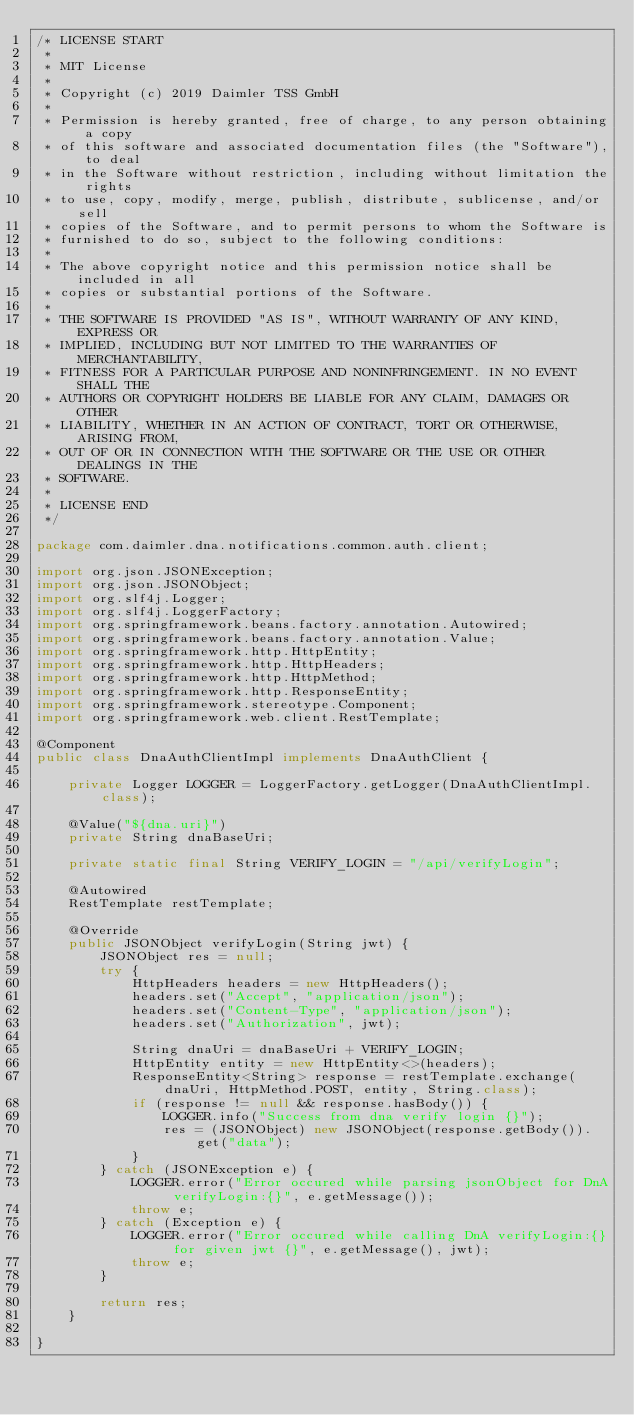Convert code to text. <code><loc_0><loc_0><loc_500><loc_500><_Java_>/* LICENSE START
 * 
 * MIT License
 * 
 * Copyright (c) 2019 Daimler TSS GmbH
 * 
 * Permission is hereby granted, free of charge, to any person obtaining a copy
 * of this software and associated documentation files (the "Software"), to deal
 * in the Software without restriction, including without limitation the rights
 * to use, copy, modify, merge, publish, distribute, sublicense, and/or sell
 * copies of the Software, and to permit persons to whom the Software is
 * furnished to do so, subject to the following conditions:
 * 
 * The above copyright notice and this permission notice shall be included in all
 * copies or substantial portions of the Software.
 * 
 * THE SOFTWARE IS PROVIDED "AS IS", WITHOUT WARRANTY OF ANY KIND, EXPRESS OR
 * IMPLIED, INCLUDING BUT NOT LIMITED TO THE WARRANTIES OF MERCHANTABILITY,
 * FITNESS FOR A PARTICULAR PURPOSE AND NONINFRINGEMENT. IN NO EVENT SHALL THE
 * AUTHORS OR COPYRIGHT HOLDERS BE LIABLE FOR ANY CLAIM, DAMAGES OR OTHER
 * LIABILITY, WHETHER IN AN ACTION OF CONTRACT, TORT OR OTHERWISE, ARISING FROM,
 * OUT OF OR IN CONNECTION WITH THE SOFTWARE OR THE USE OR OTHER DEALINGS IN THE
 * SOFTWARE.
 * 
 * LICENSE END 
 */

package com.daimler.dna.notifications.common.auth.client;

import org.json.JSONException;
import org.json.JSONObject;
import org.slf4j.Logger;
import org.slf4j.LoggerFactory;
import org.springframework.beans.factory.annotation.Autowired;
import org.springframework.beans.factory.annotation.Value;
import org.springframework.http.HttpEntity;
import org.springframework.http.HttpHeaders;
import org.springframework.http.HttpMethod;
import org.springframework.http.ResponseEntity;
import org.springframework.stereotype.Component;
import org.springframework.web.client.RestTemplate;

@Component
public class DnaAuthClientImpl implements DnaAuthClient {

	private Logger LOGGER = LoggerFactory.getLogger(DnaAuthClientImpl.class);

	@Value("${dna.uri}")
	private String dnaBaseUri;

	private static final String VERIFY_LOGIN = "/api/verifyLogin";

	@Autowired
	RestTemplate restTemplate;

	@Override
	public JSONObject verifyLogin(String jwt) {
		JSONObject res = null;
		try {
			HttpHeaders headers = new HttpHeaders();
			headers.set("Accept", "application/json");
			headers.set("Content-Type", "application/json");
			headers.set("Authorization", jwt);

			String dnaUri = dnaBaseUri + VERIFY_LOGIN;
			HttpEntity entity = new HttpEntity<>(headers);
			ResponseEntity<String> response = restTemplate.exchange(dnaUri, HttpMethod.POST, entity, String.class);
			if (response != null && response.hasBody()) {
				LOGGER.info("Success from dna verify login {}");
				res = (JSONObject) new JSONObject(response.getBody()).get("data");
			}
		} catch (JSONException e) {
			LOGGER.error("Error occured while parsing jsonObject for DnA verifyLogin:{}", e.getMessage());
			throw e;
		} catch (Exception e) {
			LOGGER.error("Error occured while calling DnA verifyLogin:{} for given jwt {}", e.getMessage(), jwt);
			throw e;
		}

		return res;
	}

}
</code> 